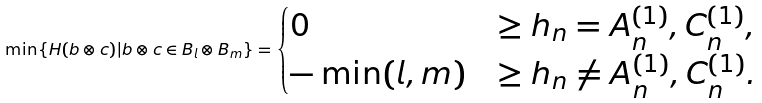Convert formula to latex. <formula><loc_0><loc_0><loc_500><loc_500>\min \{ H ( b \otimes c ) | b \otimes c \in B _ { l } \otimes B _ { m } \} = \begin{cases} 0 & \geq h _ { n } = A ^ { ( 1 ) } _ { n } , C ^ { ( 1 ) } _ { n } , \\ - \min ( l , m ) & \geq h _ { n } \neq A ^ { ( 1 ) } _ { n } , C ^ { ( 1 ) } _ { n } . \end{cases}</formula> 